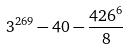Convert formula to latex. <formula><loc_0><loc_0><loc_500><loc_500>3 ^ { 2 6 9 } - 4 0 - \frac { 4 2 6 ^ { 6 } } { 8 }</formula> 